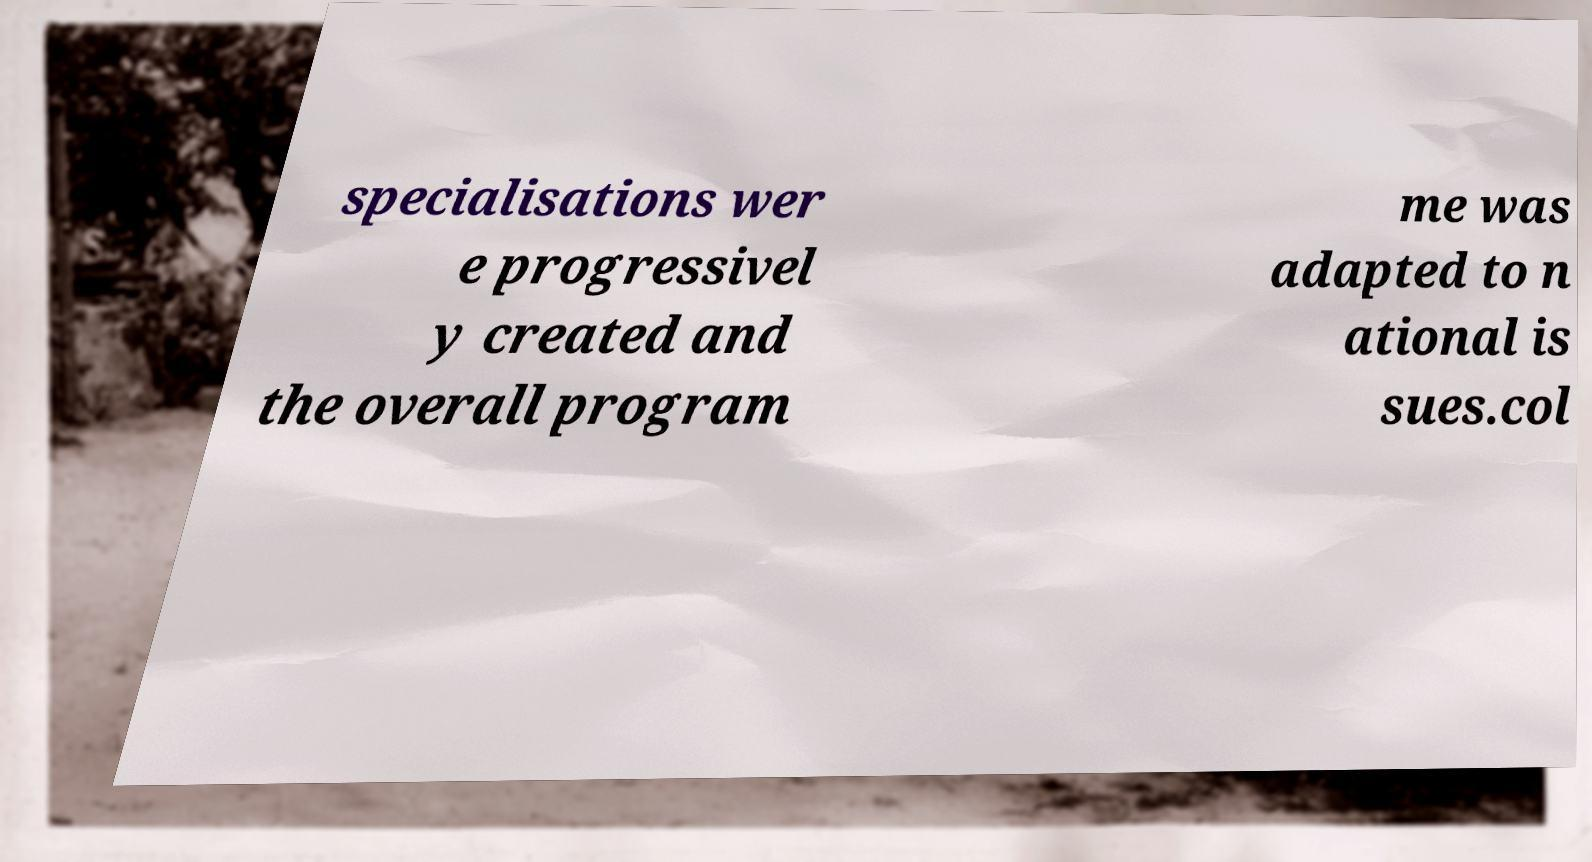Could you extract and type out the text from this image? specialisations wer e progressivel y created and the overall program me was adapted to n ational is sues.col 